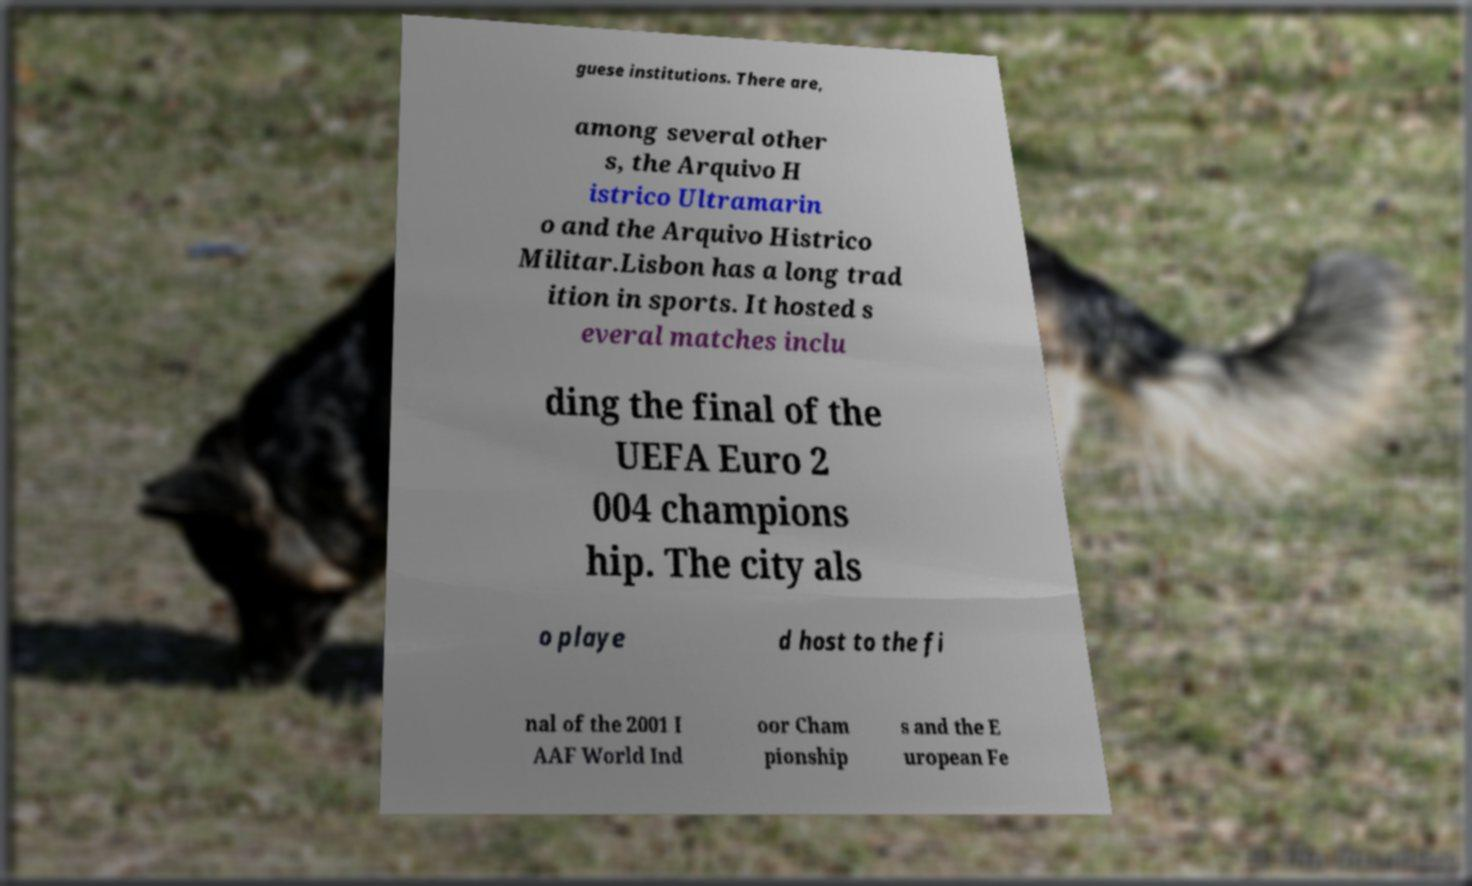What messages or text are displayed in this image? I need them in a readable, typed format. guese institutions. There are, among several other s, the Arquivo H istrico Ultramarin o and the Arquivo Histrico Militar.Lisbon has a long trad ition in sports. It hosted s everal matches inclu ding the final of the UEFA Euro 2 004 champions hip. The city als o playe d host to the fi nal of the 2001 I AAF World Ind oor Cham pionship s and the E uropean Fe 